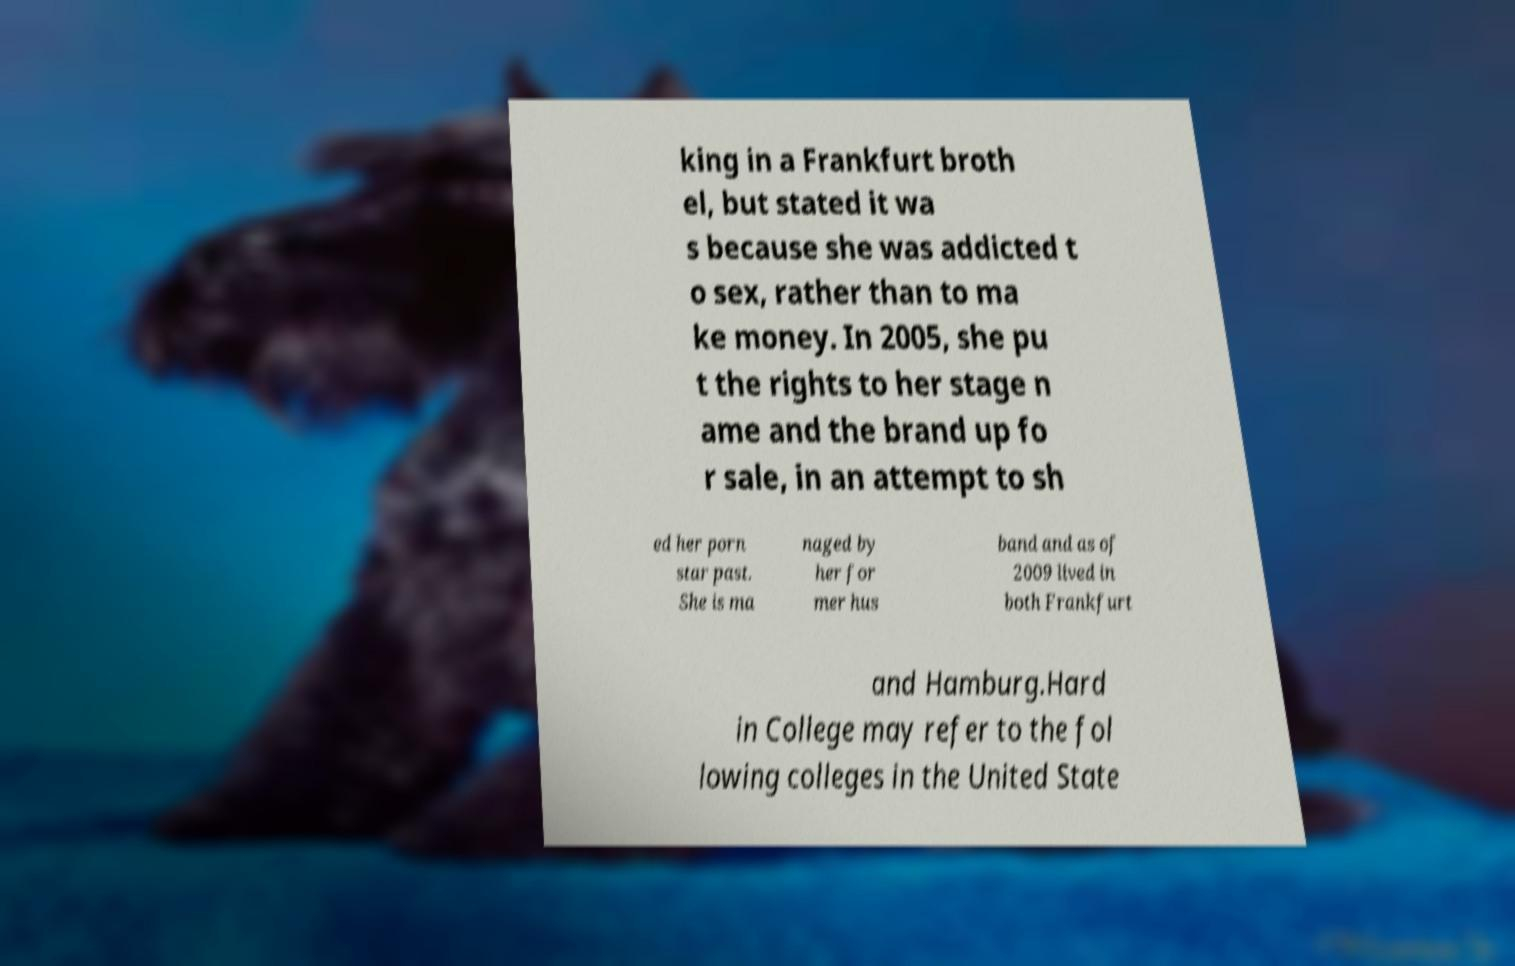There's text embedded in this image that I need extracted. Can you transcribe it verbatim? king in a Frankfurt broth el, but stated it wa s because she was addicted t o sex, rather than to ma ke money. In 2005, she pu t the rights to her stage n ame and the brand up fo r sale, in an attempt to sh ed her porn star past. She is ma naged by her for mer hus band and as of 2009 lived in both Frankfurt and Hamburg.Hard in College may refer to the fol lowing colleges in the United State 